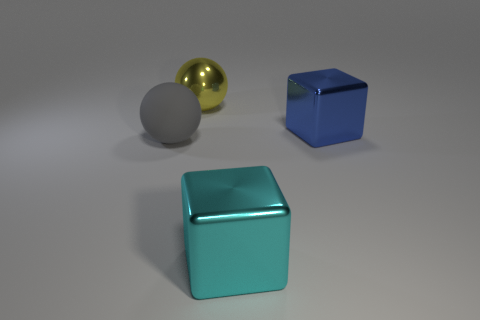There is a large ball in front of the big blue block in front of the yellow ball; what is it made of?
Your answer should be very brief. Rubber. What material is the sphere in front of the metallic cube that is behind the large block that is in front of the blue metal object made of?
Ensure brevity in your answer.  Rubber. What color is the large metal object in front of the rubber ball?
Ensure brevity in your answer.  Cyan. How big is the metallic block behind the thing left of the large shiny sphere?
Your response must be concise. Large. Is the number of big gray things to the right of the big cyan object the same as the number of spheres that are on the left side of the yellow metal thing?
Keep it short and to the point. No. The large sphere that is made of the same material as the cyan cube is what color?
Keep it short and to the point. Yellow. Are the blue cube and the large sphere that is in front of the blue metallic cube made of the same material?
Offer a very short reply. No. There is a thing that is behind the gray object and right of the large yellow metallic thing; what is its color?
Offer a very short reply. Blue. What number of cubes are either yellow shiny objects or gray matte objects?
Give a very brief answer. 0. Does the rubber object have the same shape as the big metal object to the left of the cyan metallic object?
Give a very brief answer. Yes. 